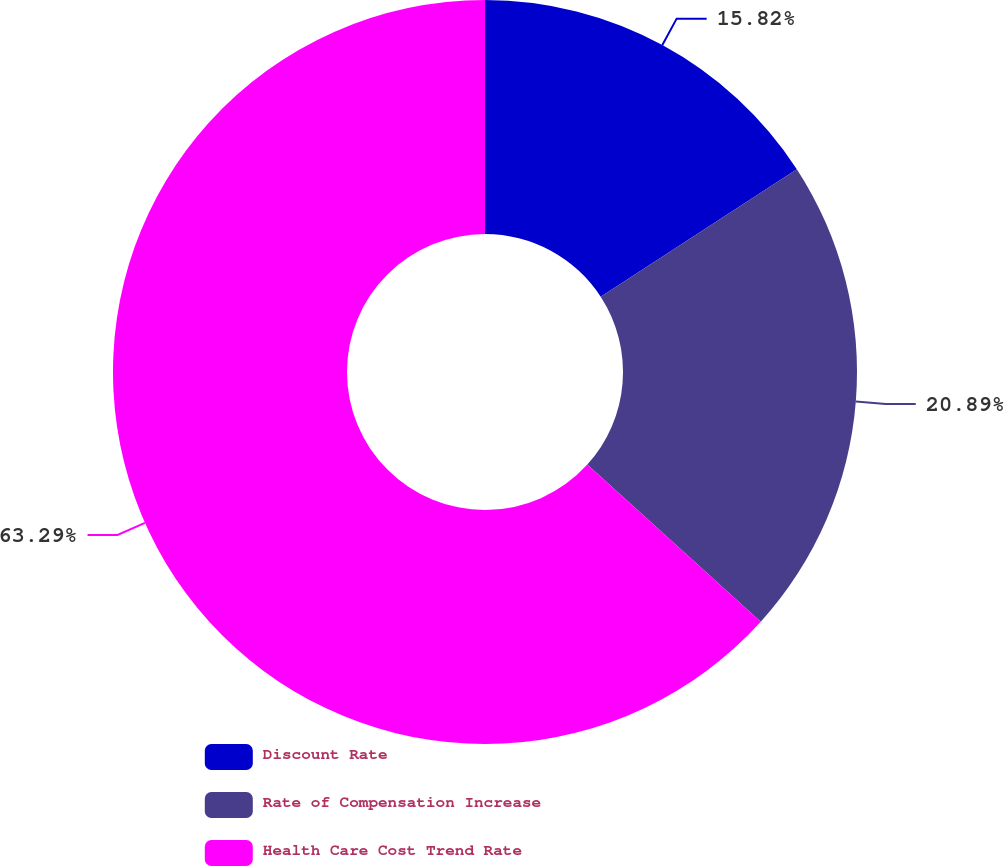Convert chart. <chart><loc_0><loc_0><loc_500><loc_500><pie_chart><fcel>Discount Rate<fcel>Rate of Compensation Increase<fcel>Health Care Cost Trend Rate<nl><fcel>15.82%<fcel>20.89%<fcel>63.29%<nl></chart> 